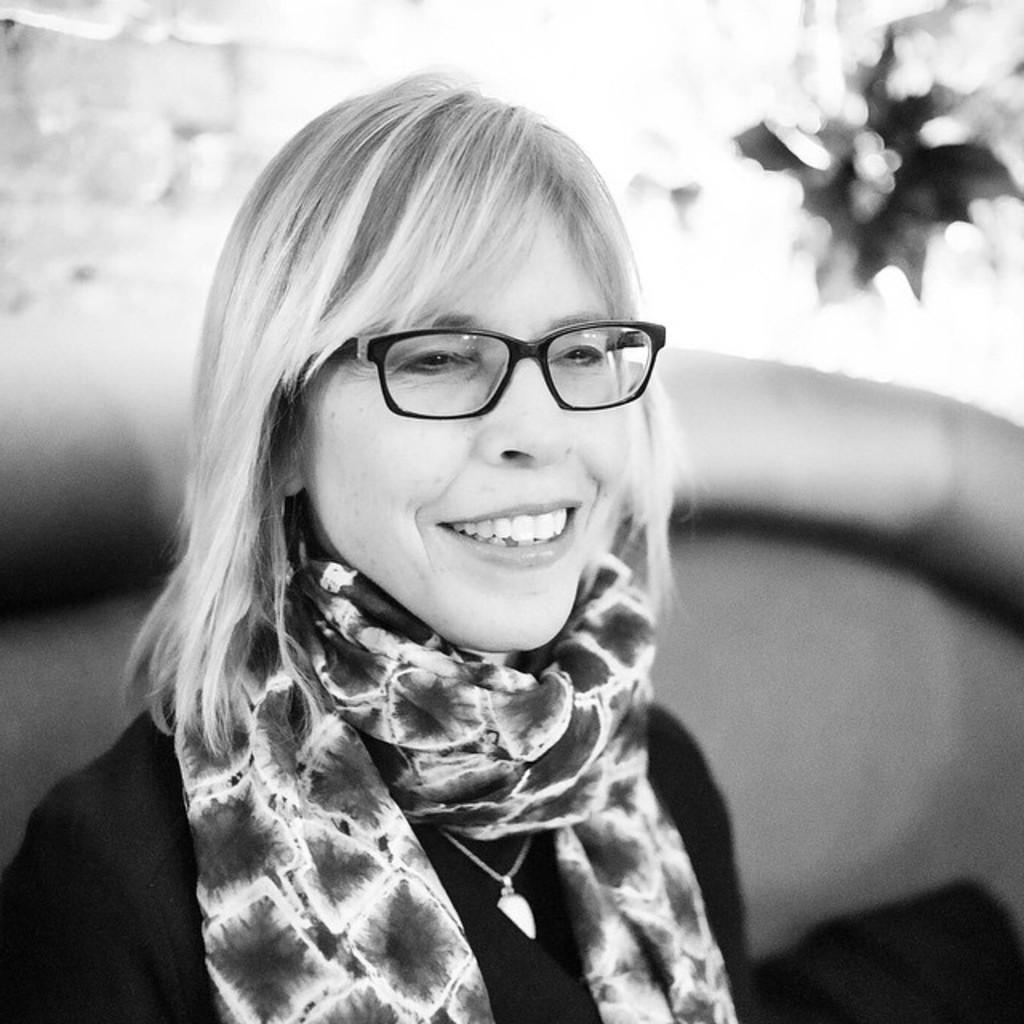Could you give a brief overview of what you see in this image? In this picture we can see a woman wore spectacles, smiling and in the background it is blur. 